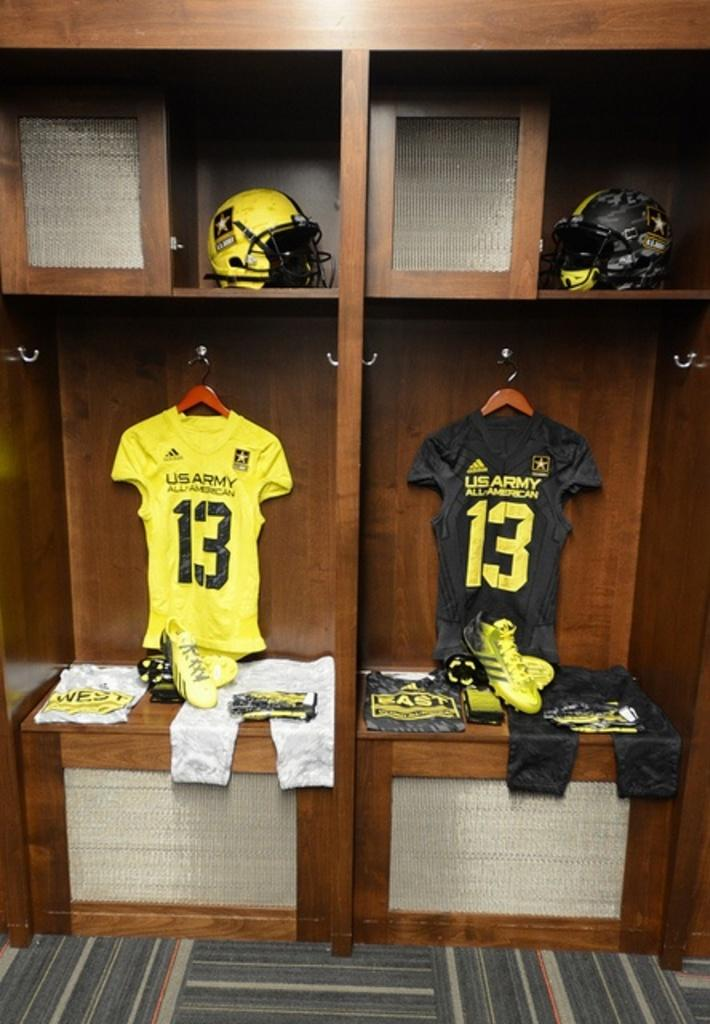<image>
Describe the image concisely. Two U.S. Army jerseys with the number 13 on them. 